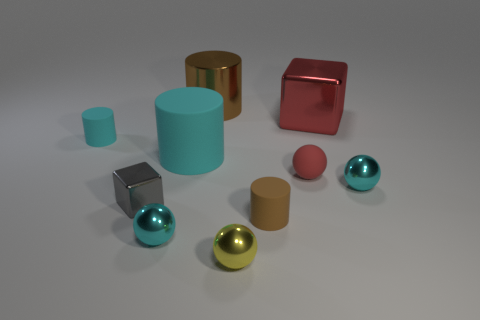Subtract all balls. How many objects are left? 6 Subtract 2 cyan cylinders. How many objects are left? 8 Subtract all tiny blue metallic spheres. Subtract all cyan balls. How many objects are left? 8 Add 8 big cylinders. How many big cylinders are left? 10 Add 6 red things. How many red things exist? 8 